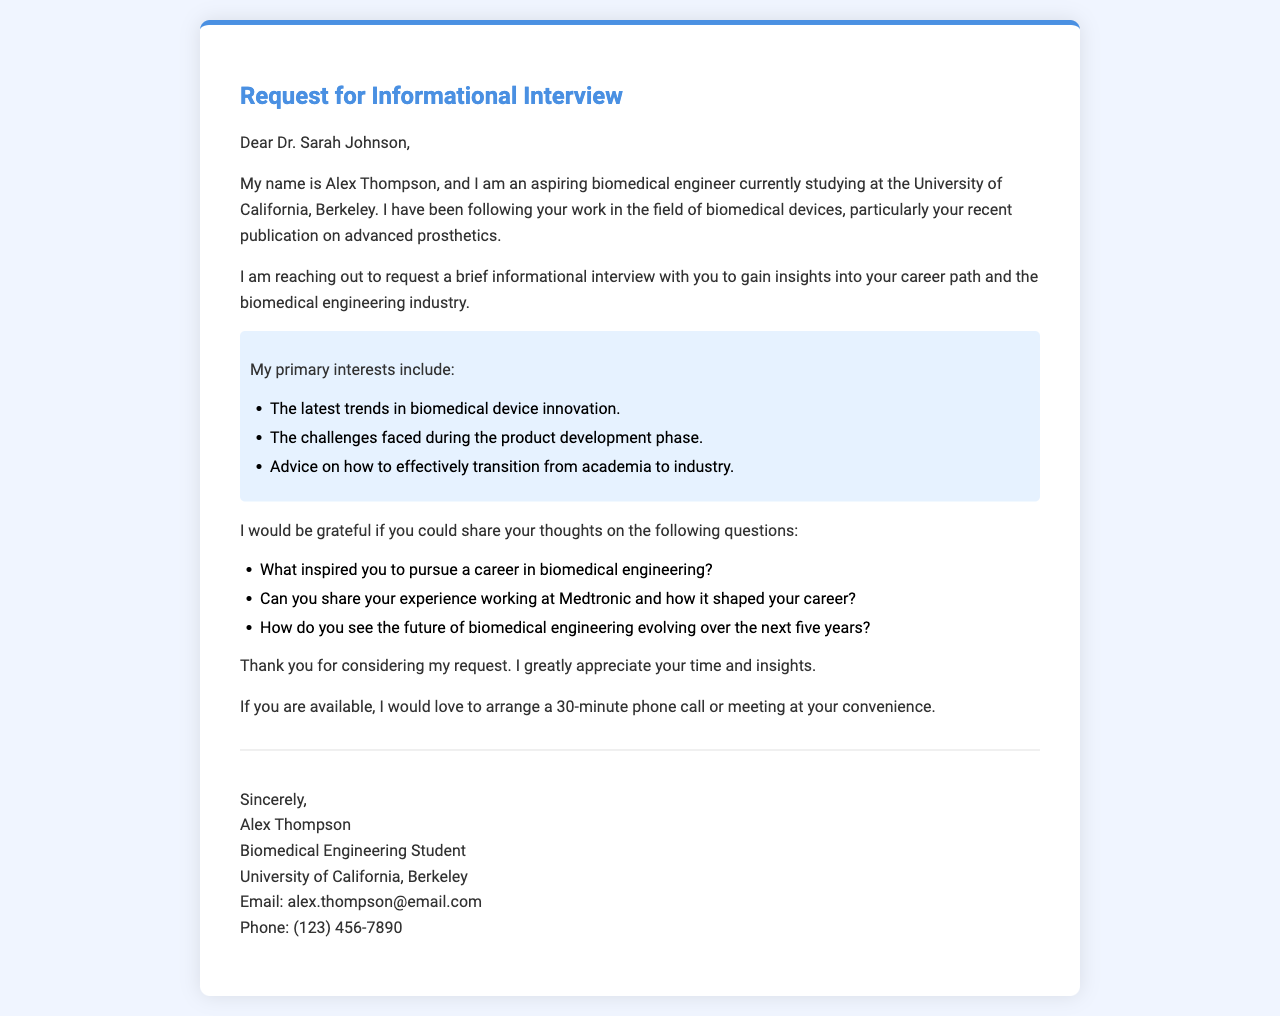What is the name of the sender? The name of the sender is mentioned in the closing section of the letter.
Answer: Alex Thompson What is the recipient's title? The title of the recipient is indicated in the salutation of the letter.
Answer: Dr What university is the sender attending? The university's name is provided in the introduction of the letter.
Answer: University of California, Berkeley What is one of the sender's primary interests? One of the sender's interests is listed in the highlighted section of the letter.
Answer: The latest trends in biomedical device innovation How long does the sender wish to arrange the informational interview? The desired duration for the interview is specified towards the end of the letter.
Answer: 30 minutes What is one question the sender wants to ask the recipient? One of the questions the sender wishes to ask is found in the list provided in the letter.
Answer: What inspired you to pursue a career in biomedical engineering? What is the sender's email address? The sender's contact information is detailed at the end of the letter.
Answer: alex.thompson@email.com Which company does the recipient have experience working with? The company mentioned in relation to the recipient's experience is included in the questions section.
Answer: Medtronic What is the overall purpose of the letter? The purpose of the letter is mentioned in the initial paragraphs.
Answer: Request for an informational interview 